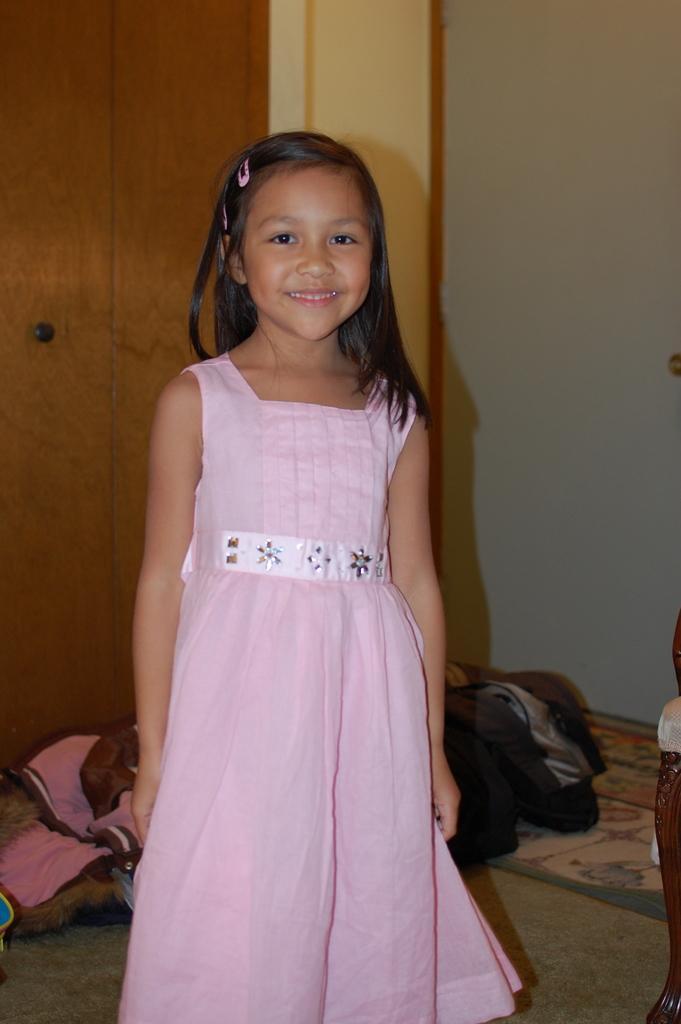In one or two sentences, can you explain what this image depicts? This image consists of a girl wearing a pink dress. At the bottom, there is a floor. In the background, we can see a cupboard and a wall. And there are blankets on the floor. 